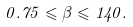<formula> <loc_0><loc_0><loc_500><loc_500>0 . 7 5 \leqslant \beta \leqslant 1 4 0 .</formula> 